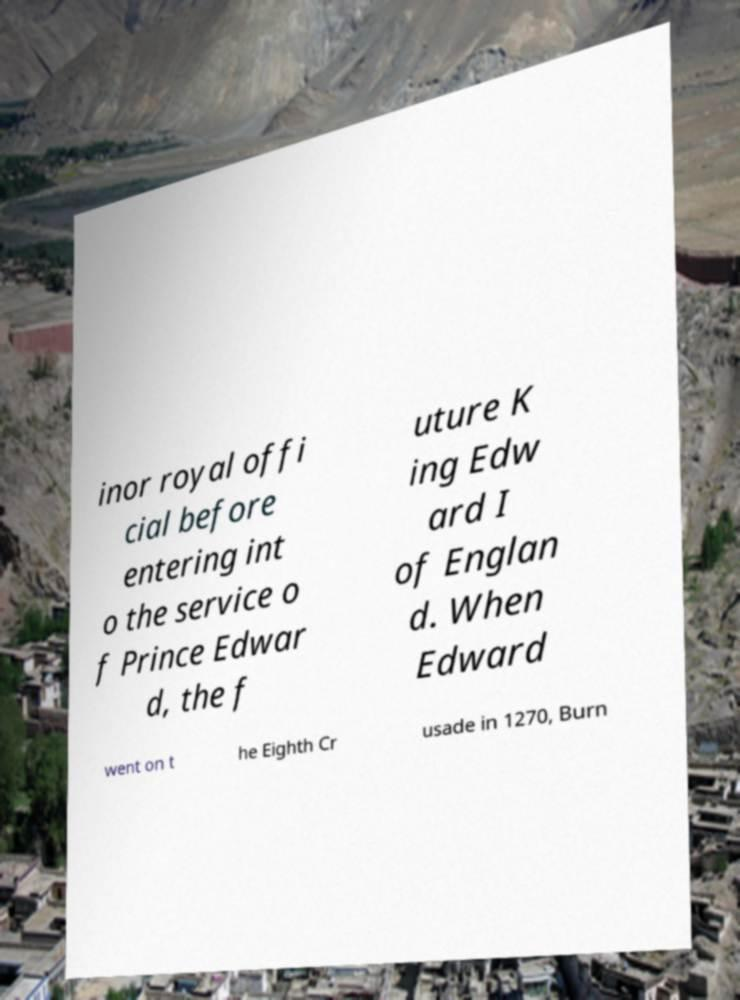Please identify and transcribe the text found in this image. inor royal offi cial before entering int o the service o f Prince Edwar d, the f uture K ing Edw ard I of Englan d. When Edward went on t he Eighth Cr usade in 1270, Burn 